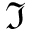<formula> <loc_0><loc_0><loc_500><loc_500>\Im</formula> 